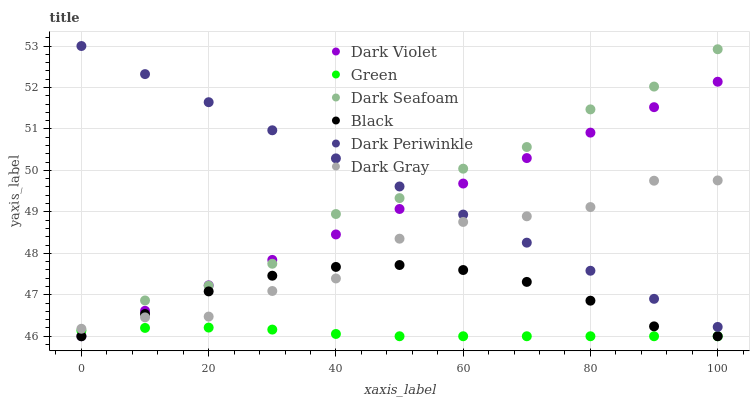Does Green have the minimum area under the curve?
Answer yes or no. Yes. Does Dark Periwinkle have the maximum area under the curve?
Answer yes or no. Yes. Does Dark Gray have the minimum area under the curve?
Answer yes or no. No. Does Dark Gray have the maximum area under the curve?
Answer yes or no. No. Is Dark Periwinkle the smoothest?
Answer yes or no. Yes. Is Dark Gray the roughest?
Answer yes or no. Yes. Is Dark Seafoam the smoothest?
Answer yes or no. No. Is Dark Seafoam the roughest?
Answer yes or no. No. Does Dark Violet have the lowest value?
Answer yes or no. Yes. Does Dark Gray have the lowest value?
Answer yes or no. No. Does Dark Periwinkle have the highest value?
Answer yes or no. Yes. Does Dark Gray have the highest value?
Answer yes or no. No. Is Green less than Dark Periwinkle?
Answer yes or no. Yes. Is Dark Periwinkle greater than Black?
Answer yes or no. Yes. Does Green intersect Dark Violet?
Answer yes or no. Yes. Is Green less than Dark Violet?
Answer yes or no. No. Is Green greater than Dark Violet?
Answer yes or no. No. Does Green intersect Dark Periwinkle?
Answer yes or no. No. 